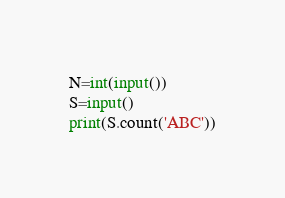Convert code to text. <code><loc_0><loc_0><loc_500><loc_500><_Python_>N=int(input())
S=input()
print(S.count('ABC'))</code> 